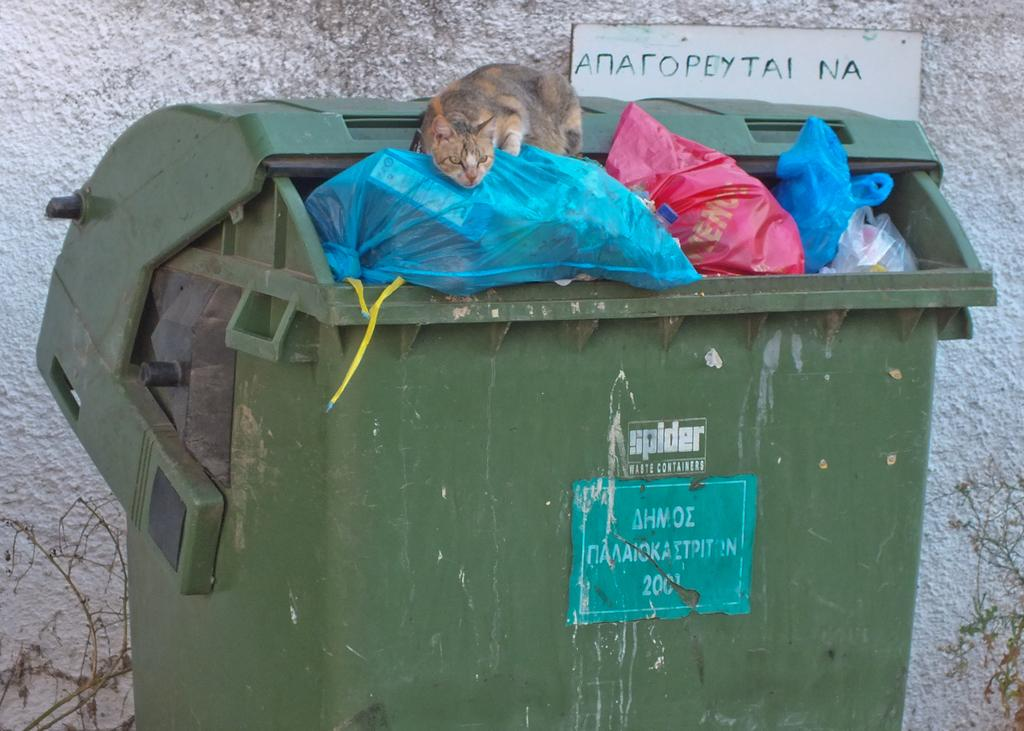What type of animal is in the image? There is a cat in the image. Where is the cat located in the image? The cat is on top of trash in a trash bin. What can be seen on the wall behind the bin? There is a name board on a wall behind the bin. What type of vegetation is present in the image? There are plants in the bottom left and right of the image. What type of tooth is visible in the image? There is no tooth visible in the image. Is the cat standing on the ground in the image? The cat is not standing on the ground; it is on top of trash in a trash bin. 